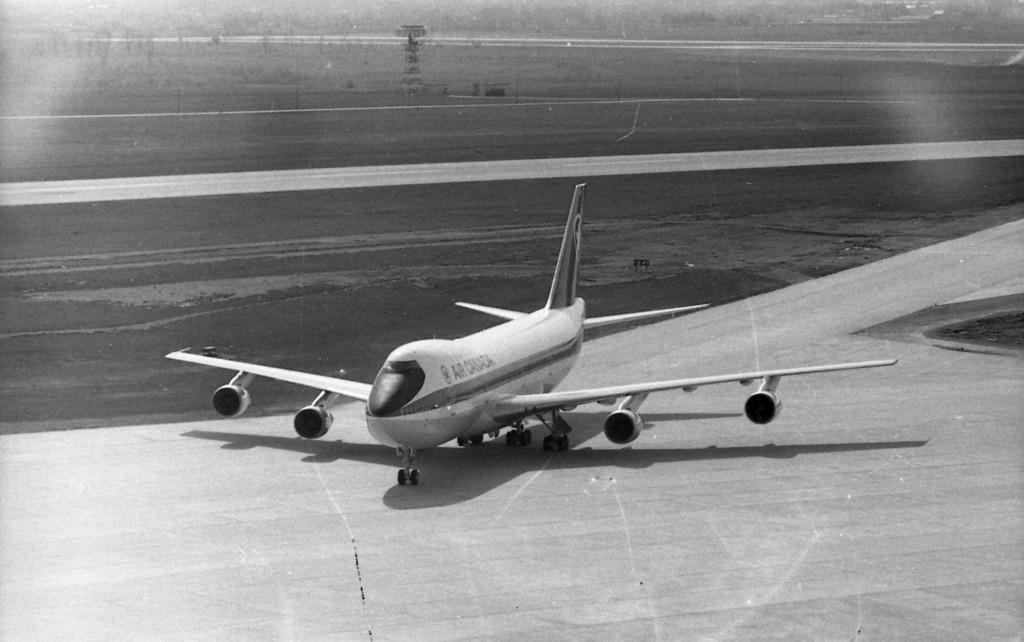<image>
Give a short and clear explanation of the subsequent image. an Air Canada plane on the tarmac in black and white 